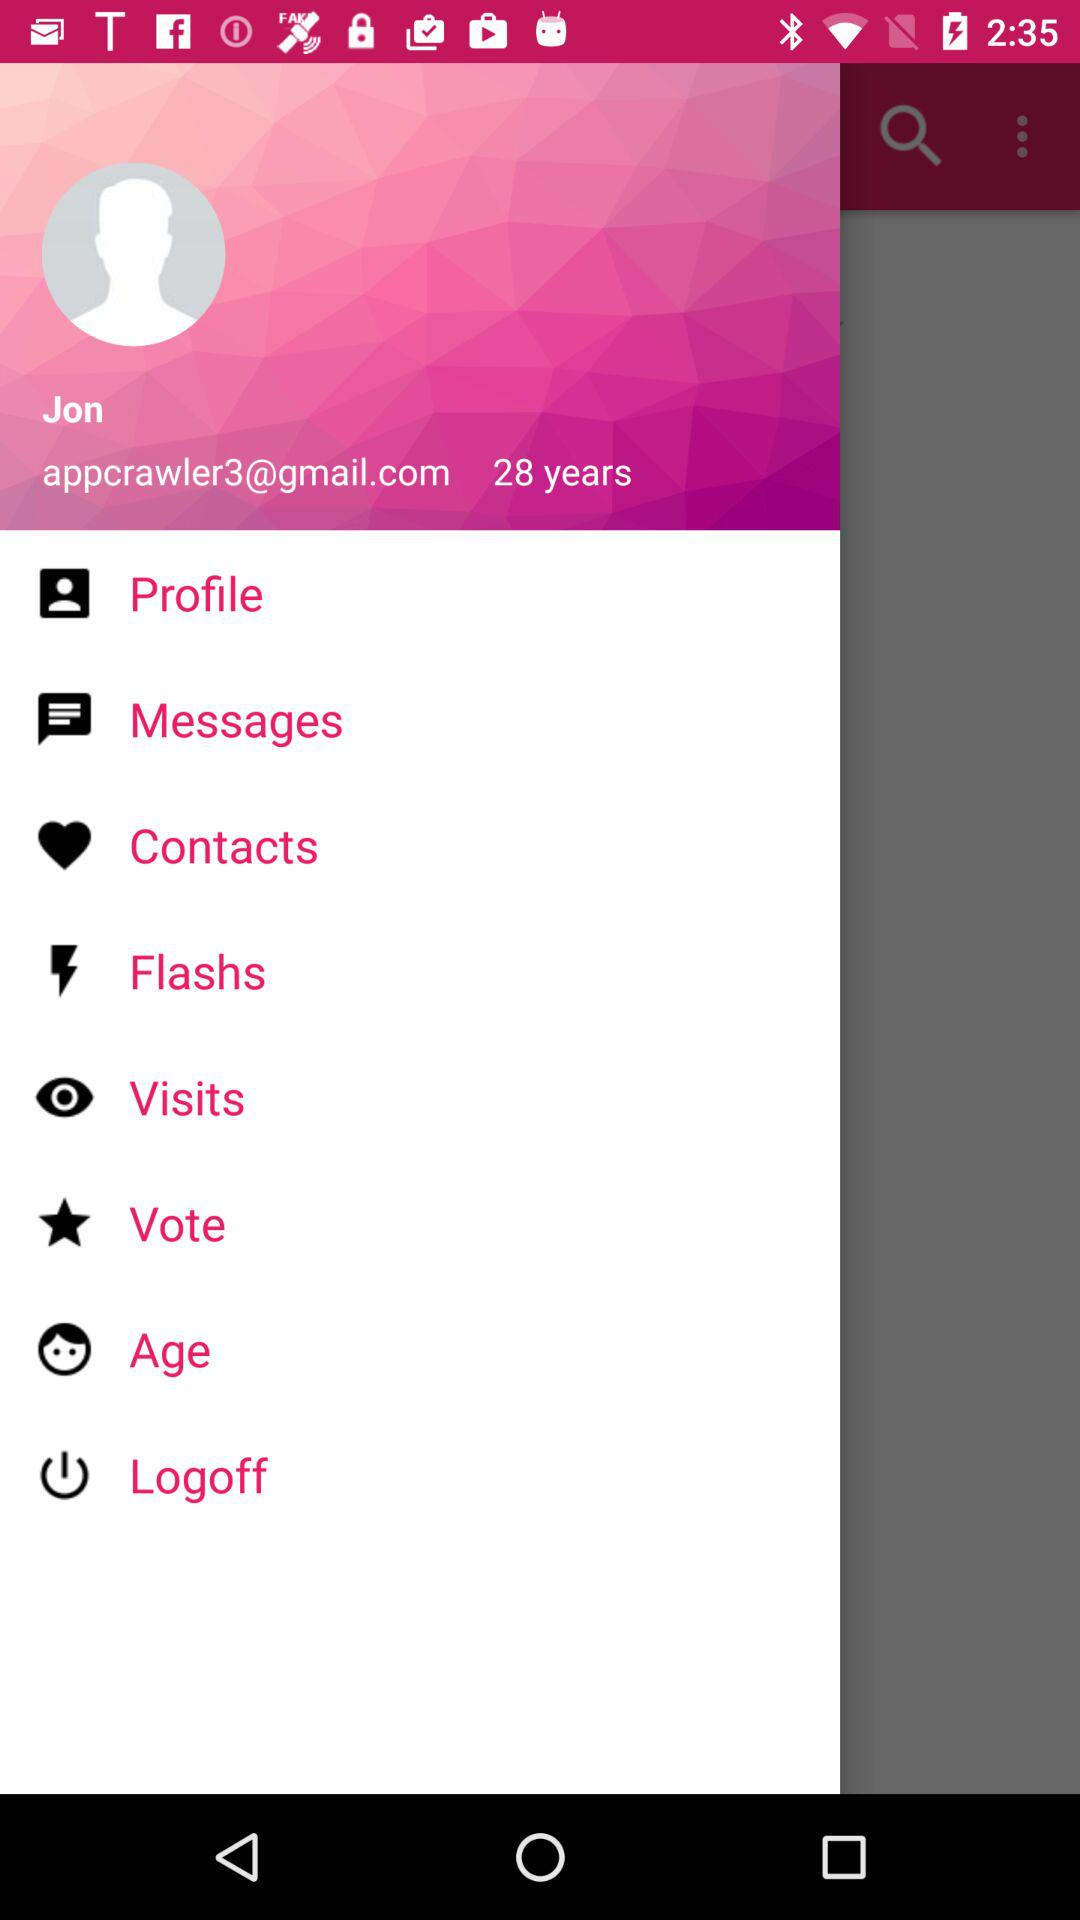What is the name of the user? The name of the user is Jon. 